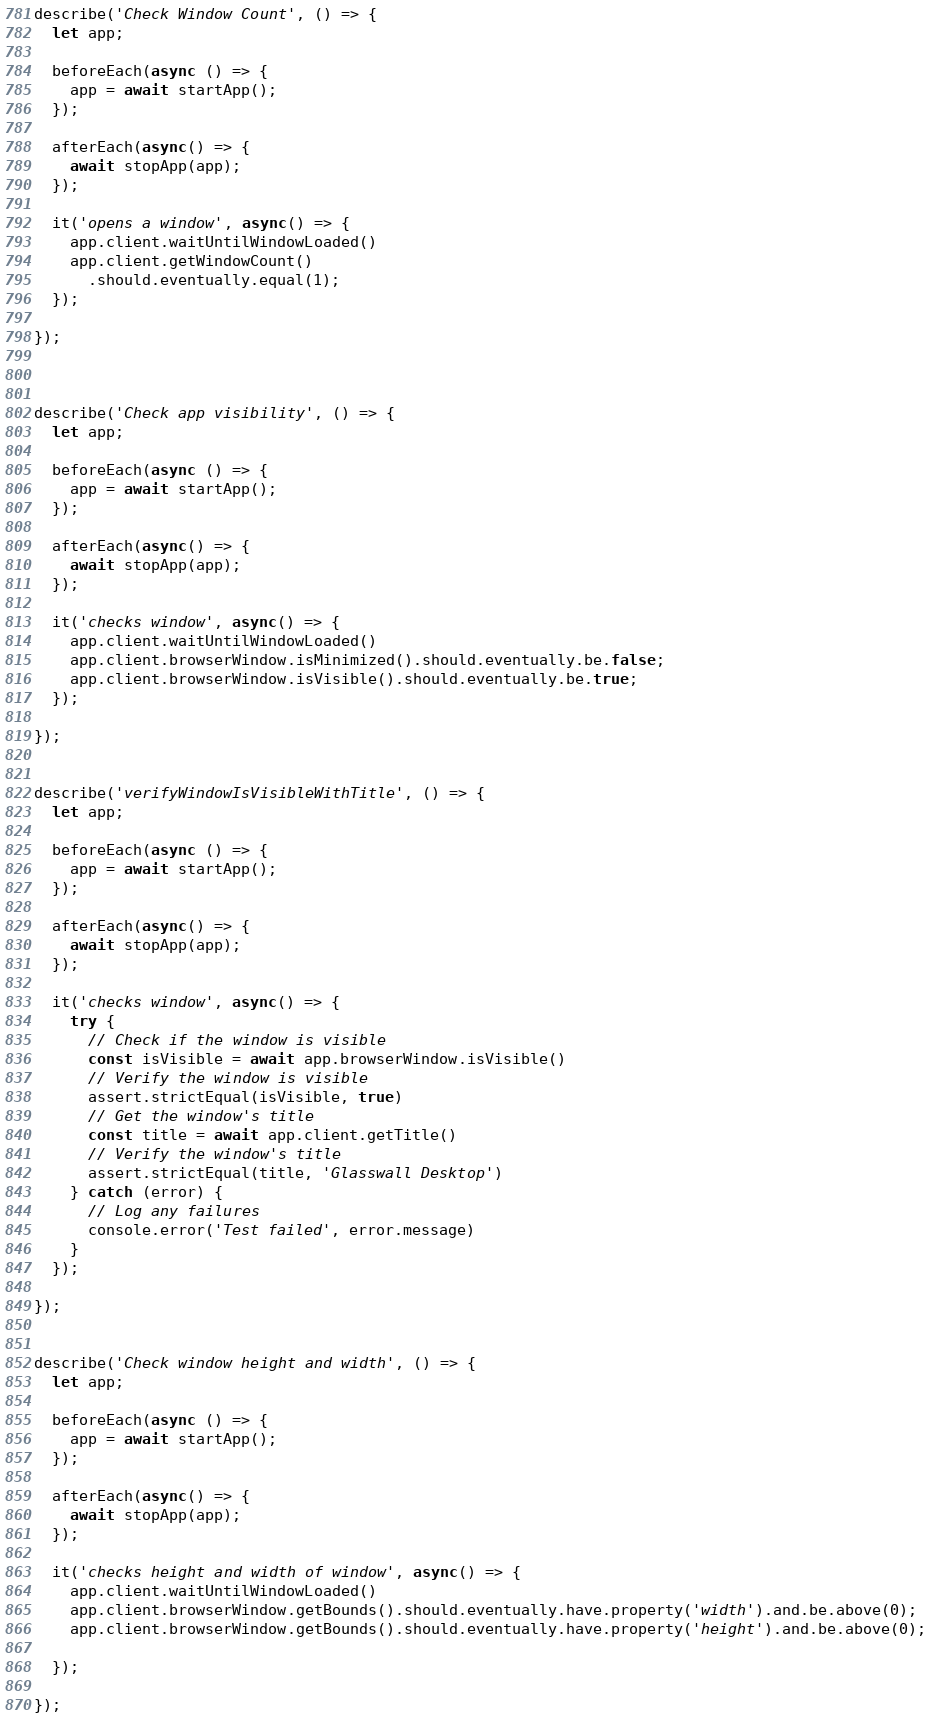<code> <loc_0><loc_0><loc_500><loc_500><_JavaScript_>

describe('Check Window Count', () => {  
  let app;

  beforeEach(async () => {
    app = await startApp();
  });

  afterEach(async() => {
    await stopApp(app);
  });

  it('opens a window', async() => {
    app.client.waitUntilWindowLoaded()
    app.client.getWindowCount()
      .should.eventually.equal(1);
  });

});



describe('Check app visibility', () => {  
  let app;

  beforeEach(async () => {
    app = await startApp();
  });

  afterEach(async() => {
    await stopApp(app);
  });

  it('checks window', async() => {
    app.client.waitUntilWindowLoaded()
    app.client.browserWindow.isMinimized().should.eventually.be.false;
    app.client.browserWindow.isVisible().should.eventually.be.true;
  });

});


describe('verifyWindowIsVisibleWithTitle', () => {  
  let app;

  beforeEach(async () => {
    app = await startApp();
  });

  afterEach(async() => {
    await stopApp(app);
  });

  it('checks window', async() => {
    try {
      // Check if the window is visible
      const isVisible = await app.browserWindow.isVisible()
      // Verify the window is visible
      assert.strictEqual(isVisible, true)
      // Get the window's title
      const title = await app.client.getTitle()
      // Verify the window's title
      assert.strictEqual(title, 'Glasswall Desktop')
    } catch (error) {
      // Log any failures
      console.error('Test failed', error.message)
    }
  });

});


describe('Check window height and width', () => {  
  let app;

  beforeEach(async () => {
    app = await startApp();
  });

  afterEach(async() => {
    await stopApp(app);
  });

  it('checks height and width of window', async() => {
    app.client.waitUntilWindowLoaded()
    app.client.browserWindow.getBounds().should.eventually.have.property('width').and.be.above(0);
    app.client.browserWindow.getBounds().should.eventually.have.property('height').and.be.above(0);
    
  });

});
</code> 